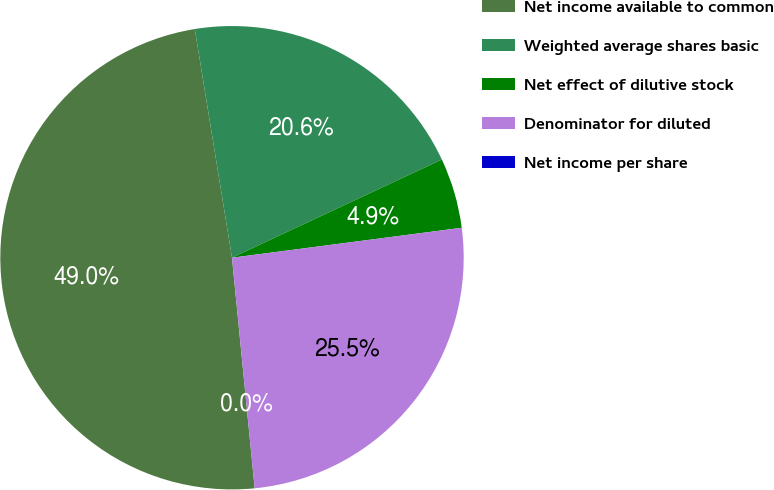Convert chart to OTSL. <chart><loc_0><loc_0><loc_500><loc_500><pie_chart><fcel>Net income available to common<fcel>Weighted average shares basic<fcel>Net effect of dilutive stock<fcel>Denominator for diluted<fcel>Net income per share<nl><fcel>48.99%<fcel>20.6%<fcel>4.9%<fcel>25.5%<fcel>0.0%<nl></chart> 